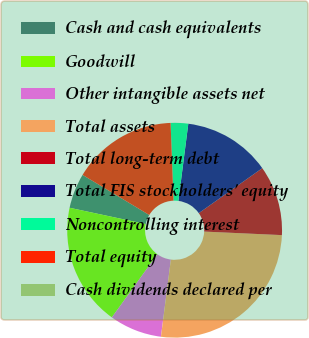Convert chart to OTSL. <chart><loc_0><loc_0><loc_500><loc_500><pie_chart><fcel>Cash and cash equivalents<fcel>Goodwill<fcel>Other intangible assets net<fcel>Total assets<fcel>Total long-term debt<fcel>Total FIS stockholders' equity<fcel>Noncontrolling interest<fcel>Total equity<fcel>Cash dividends declared per<nl><fcel>5.26%<fcel>18.42%<fcel>7.9%<fcel>26.31%<fcel>10.53%<fcel>13.16%<fcel>2.63%<fcel>15.79%<fcel>0.0%<nl></chart> 